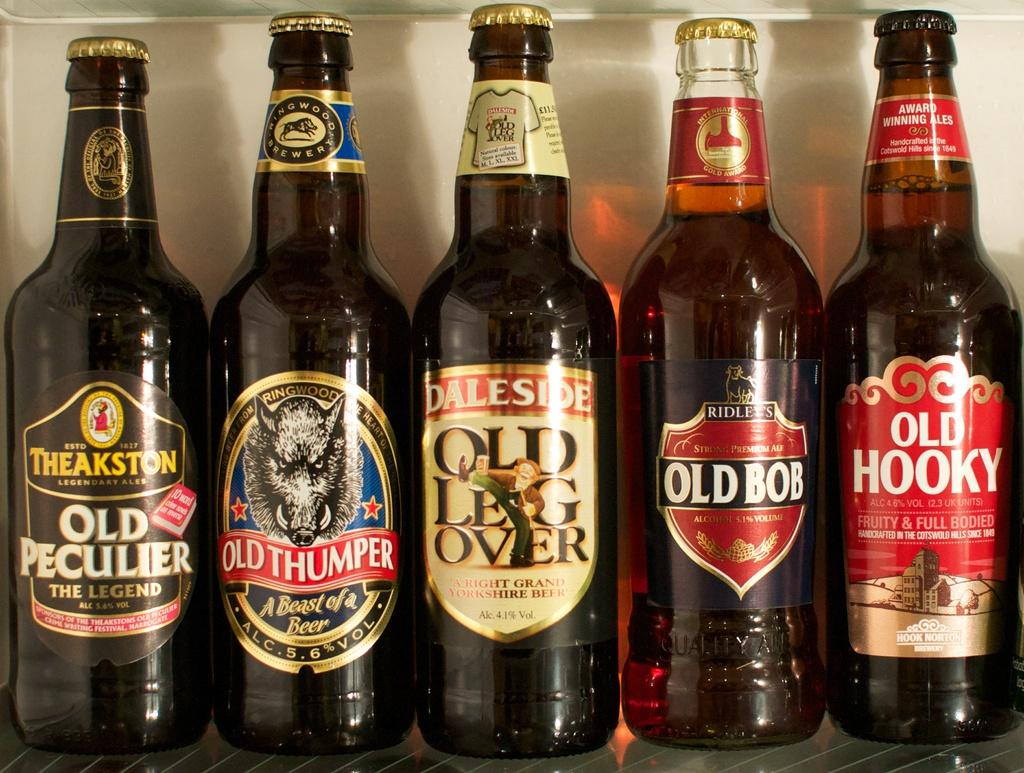What objects are present in the image? There are several bottles in the image. How many bottles are black in color? Three of the bottles are black in color. How many bottles are red in color? Two of the bottles are red in color. Where are the bottles located in the image? The bottles are placed on a table. How many snails are crawling on the red bottles in the image? There are no snails present in the image. What is the wealth status of the person who owns the bottles in the image? The image does not provide any information about the wealth status of the person who owns the bottles. 